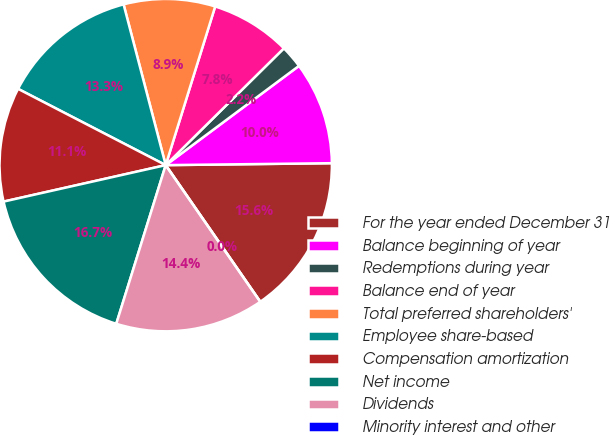Convert chart to OTSL. <chart><loc_0><loc_0><loc_500><loc_500><pie_chart><fcel>For the year ended December 31<fcel>Balance beginning of year<fcel>Redemptions during year<fcel>Balance end of year<fcel>Total preferred shareholders'<fcel>Employee share-based<fcel>Compensation amortization<fcel>Net income<fcel>Dividends<fcel>Minority interest and other<nl><fcel>15.55%<fcel>10.0%<fcel>2.22%<fcel>7.78%<fcel>8.89%<fcel>13.33%<fcel>11.11%<fcel>16.67%<fcel>14.44%<fcel>0.0%<nl></chart> 